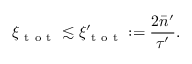Convert formula to latex. <formula><loc_0><loc_0><loc_500><loc_500>\xi _ { t o t } \lesssim \xi _ { t o t } ^ { \prime } \colon = \frac { 2 \bar { n } ^ { \prime } } { \tau ^ { \prime } } .</formula> 